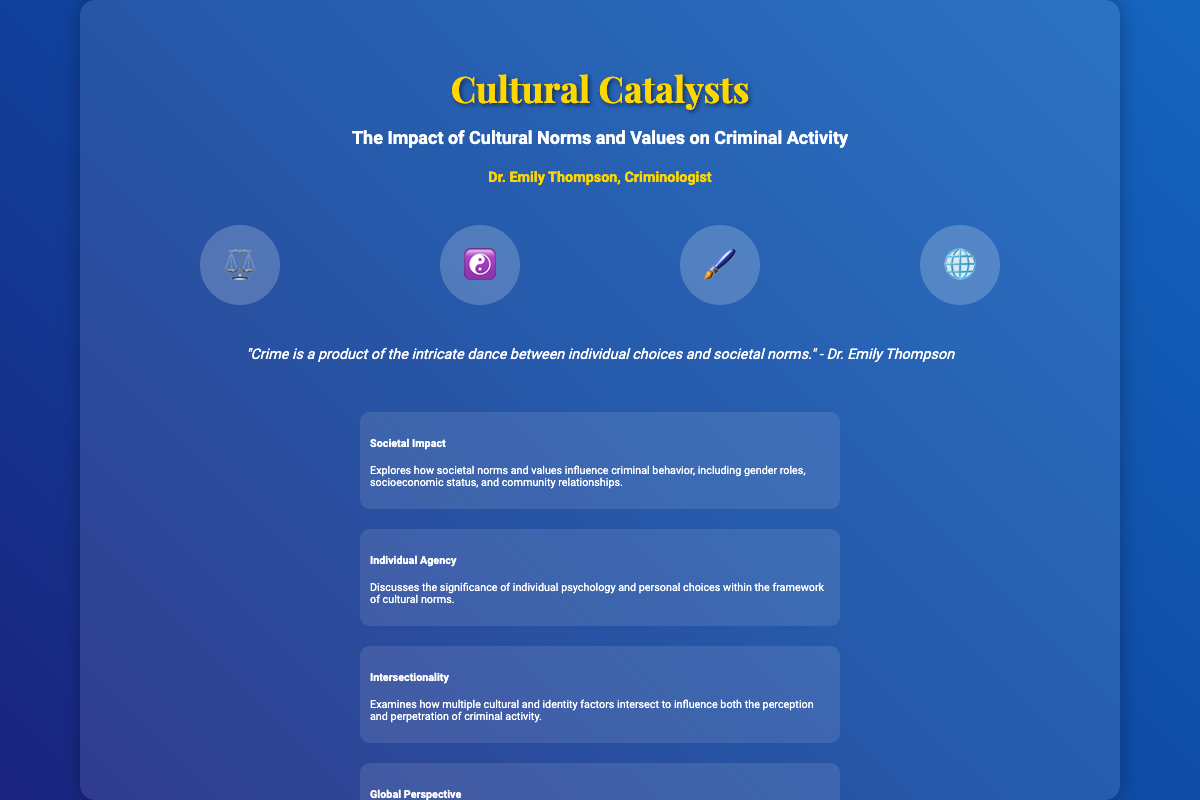What is the title of the book? The title is prominently displayed at the top of the cover, indicating the main subject of the book.
Answer: Cultural Catalysts Who is the author of the book? The author's name is listed under the title, identifying the individual who wrote the book.
Answer: Dr. Emily Thompson What cultural symbol represents justice on the cover? The symbol indicating justice is visually represented by an image associated with legal matters.
Answer: ⚖️ What is the subtitle of the book? The subtitle clarifies the focus of the book and is located directly beneath the title.
Answer: The Impact of Cultural Norms and Values on Criminal Activity How many themes are listed on the cover? The number of themes refers to the categories presented that summarize the book's main ideas.
Answer: Four What type of perspective does the book provide? This refers to the viewpoint the author takes, as indicated in the description of the themes.
Answer: Global What is the quote about crime on the cover? The quote summarizes a central idea of the book, reflecting on the relationship between individuals and society.
Answer: "Crime is a product of the intricate dance between individual choices and societal norms." What color is used for the title? The color used enhances the aesthetic appeal and visibility of the title.
Answer: Gold 